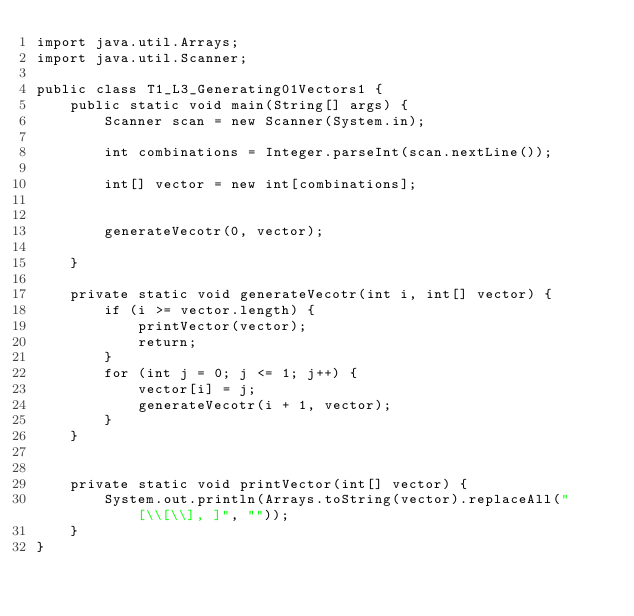<code> <loc_0><loc_0><loc_500><loc_500><_Java_>import java.util.Arrays;
import java.util.Scanner;

public class T1_L3_Generating01Vectors1 {
    public static void main(String[] args) {
        Scanner scan = new Scanner(System.in);

        int combinations = Integer.parseInt(scan.nextLine());

        int[] vector = new int[combinations];


        generateVecotr(0, vector);

    }

    private static void generateVecotr(int i, int[] vector) {
        if (i >= vector.length) {
            printVector(vector);
            return;
        }
        for (int j = 0; j <= 1; j++) {
            vector[i] = j;
            generateVecotr(i + 1, vector);
        }
    }


    private static void printVector(int[] vector) {
        System.out.println(Arrays.toString(vector).replaceAll("[\\[\\], ]", ""));
    }
}
</code> 